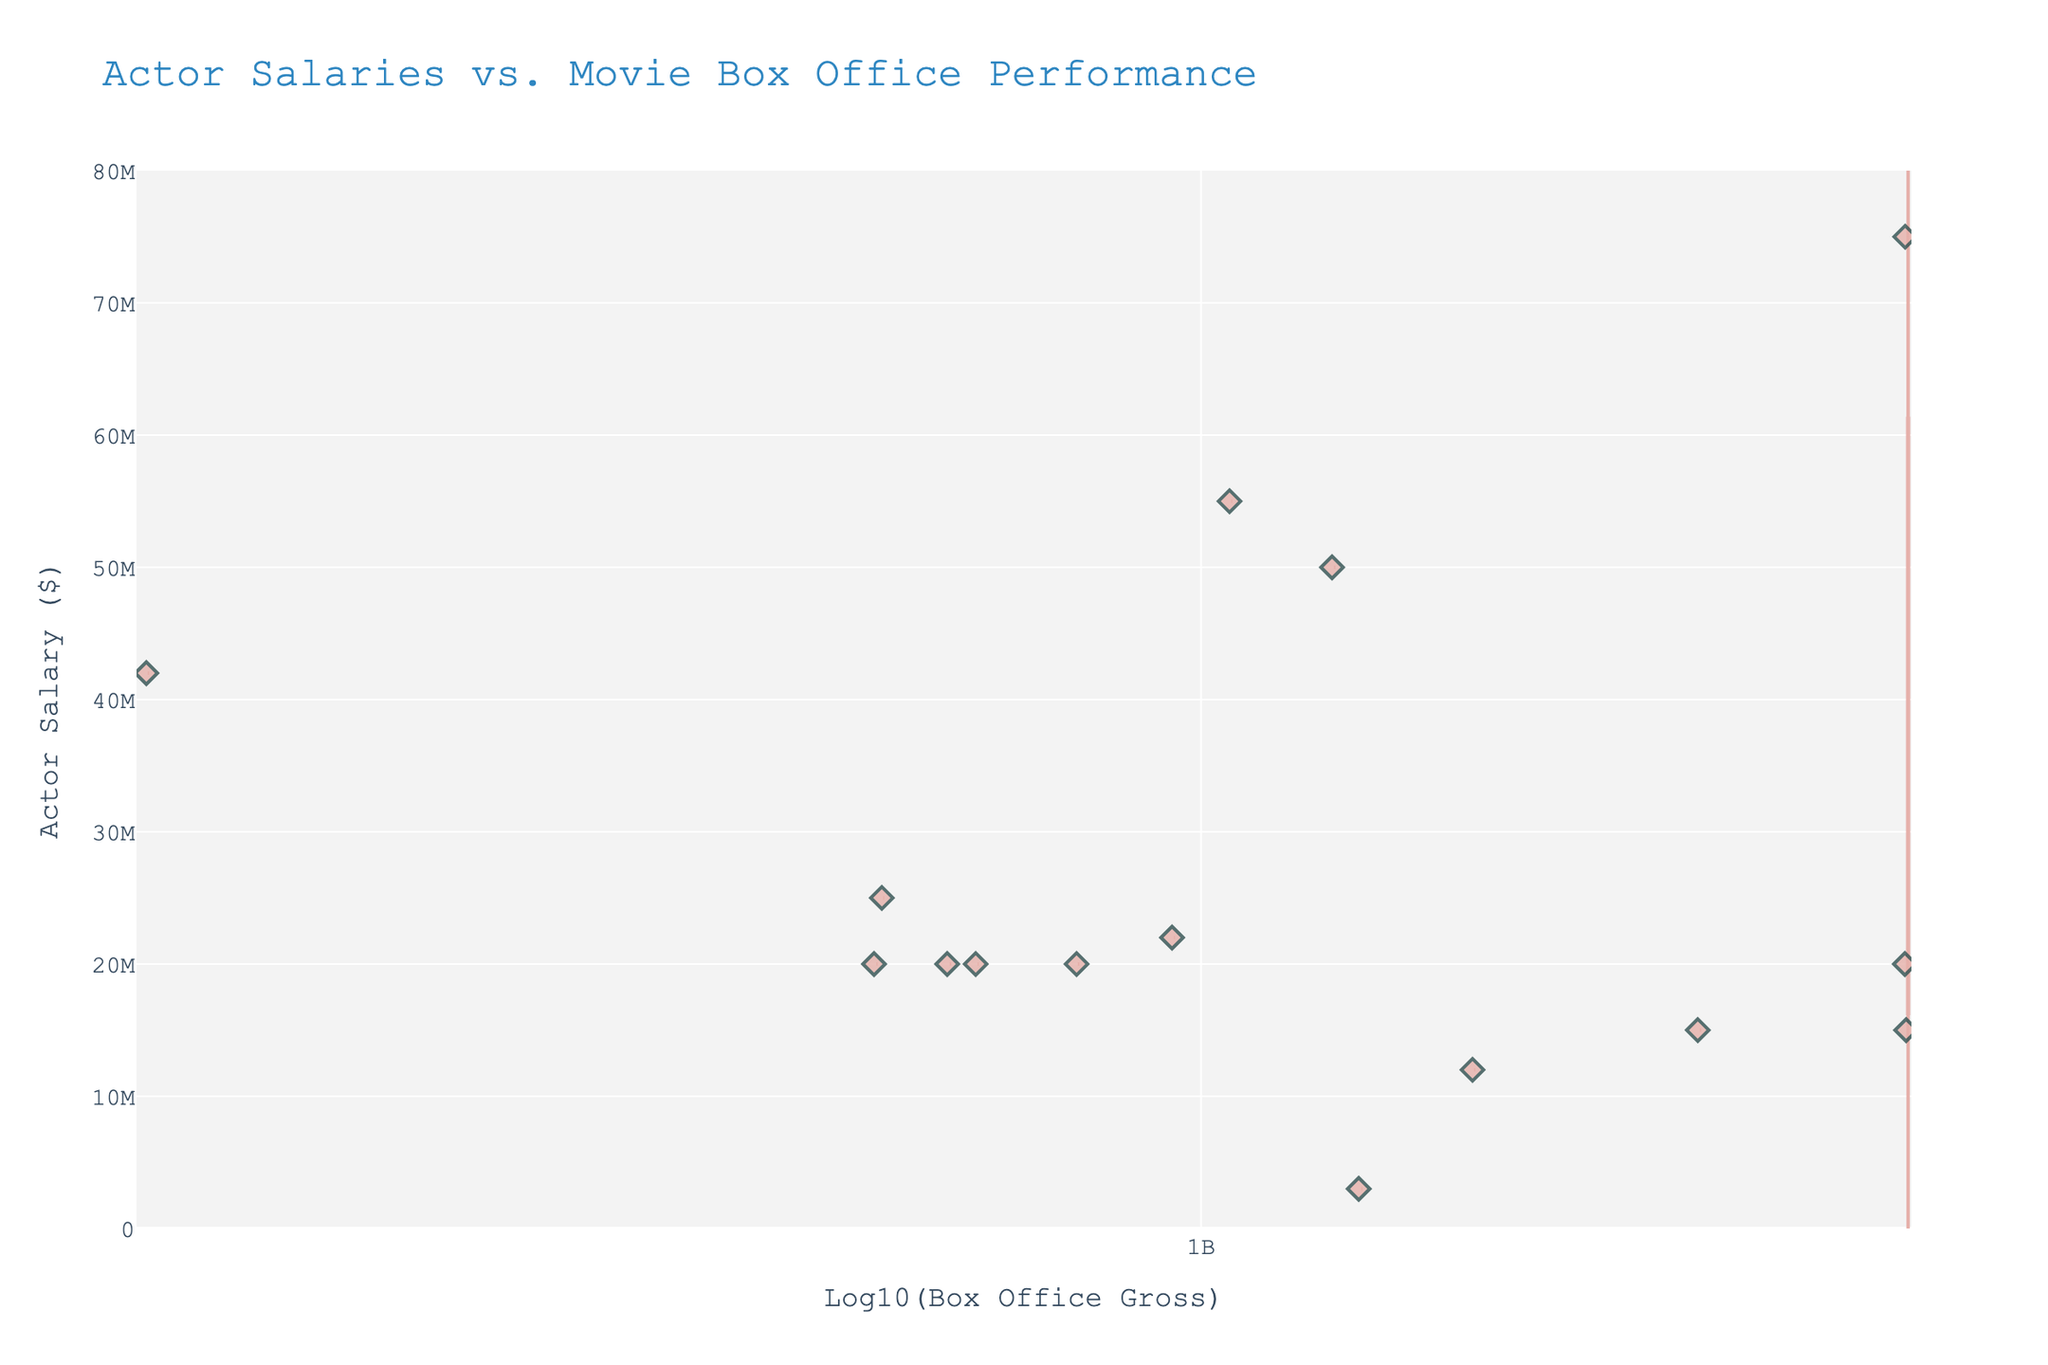What is the title of the chart? The title of the chart is displayed at the top.
Answer: Actor Salaries vs. Movie Box Office Performance What does the y-axis represent? The y-axis represents the salaries of actors in dollars.
Answer: Actor Salary ($) What does the x-axis represent? The x-axis represents the log10 of the movie box office gross. The labels such as '10M', '100M', '1B', and '10B' provide the log values in a more understandable format.
Answer: Log10(Box Office Gross) Which actor appears to have the highest salary? By observing the position of the highest point along the y-axis, which is labeled with the actor's name.
Answer: Robert Downey Jr How many actors have salaries above $20,000,000? Count the data points above the $20,000,000 mark on the violin chart.
Answer: 6 Which actor's salary had the largest individual spread in the data points along the y-axis? Identify the actor associated with the box plot that has the largest vertical extent within the violin plots.
Answer: Cameron Diaz Is there any actor who starred in multiple movies in this data set? Look for any repeated actor names in the hover data points.
Answer: Robert Downey Jr Which actor participated in a movie that grossed more than $2 billion? Find the data point on the x-axis that corresponds to a log value just above '2B' and check the hover data to identify the actor.
Answer: Robert Downey Jr What is the general trend of actor salaries relative to the box office gross? Observe the overall distribution pattern of the data points on the chart.
Answer: Higher box office grosses do not necessarily correlate to higher actor salaries Between actors with movies grossing around $1 billion, who had a lower salary, and what was it? Compare the salaries of actors whose films grossed around 1 billion by checking hover data in the box plot around 9 on the x-axis.
Answer: Emma Watson, $3,000,000 